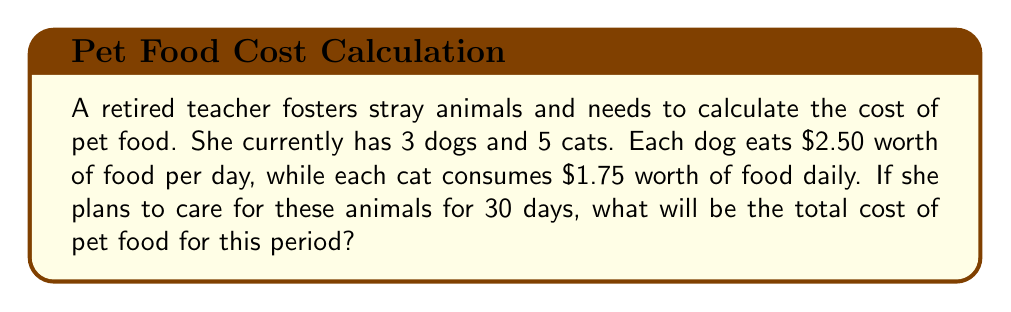Help me with this question. Let's break this problem down step-by-step:

1. Calculate the daily cost for feeding the dogs:
   $3 \text{ dogs} \times \$2.50 \text{ per dog} = \$7.50 \text{ per day}$

2. Calculate the daily cost for feeding the cats:
   $5 \text{ cats} \times \$1.75 \text{ per cat} = \$8.75 \text{ per day}$

3. Calculate the total daily cost for all animals:
   $\$7.50 + \$8.75 = \$16.25 \text{ per day}$

4. Calculate the total cost for 30 days:
   $\$16.25 \text{ per day} \times 30 \text{ days} = \$487.50$

Therefore, the total cost of pet food for 30 days will be $\$487.50$.
Answer: $\$487.50$ 